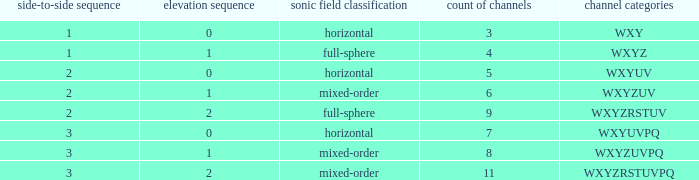If the height order is 1 and the soundfield type is mixed-order, what are all the channels? WXYZUV, WXYZUVPQ. 